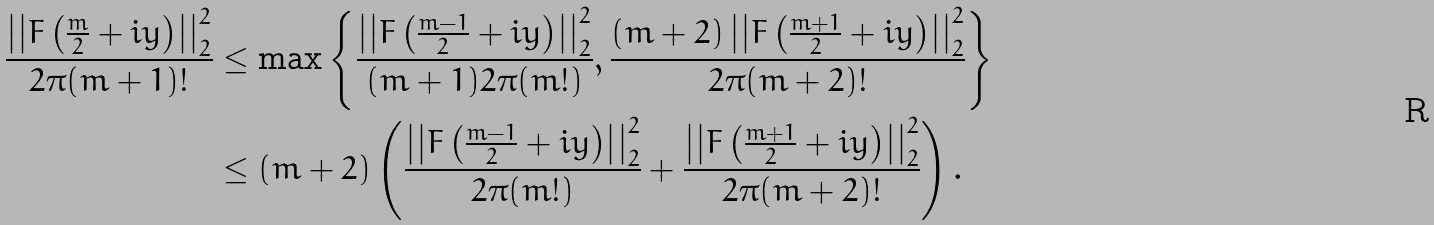<formula> <loc_0><loc_0><loc_500><loc_500>\frac { \left | \left | F \left ( \frac { m } { 2 } + i y \right ) \right | \right | _ { 2 } ^ { 2 } } { 2 \pi ( m + 1 ) ! } & \leq \max \left \{ \frac { \left | \left | F \left ( \frac { m - 1 } { 2 } + i y \right ) \right | \right | _ { 2 } ^ { 2 } } { ( m + 1 ) 2 \pi ( m ! ) } , \frac { ( m + 2 ) \left | \left | F \left ( \frac { m + 1 } { 2 } + i y \right ) \right | \right | _ { 2 } ^ { 2 } } { 2 \pi ( m + 2 ) ! } \right \} \\ & \leq ( m + 2 ) \left ( \frac { \left | \left | F \left ( \frac { m - 1 } { 2 } + i y \right ) \right | \right | _ { 2 } ^ { 2 } } { 2 \pi ( m ! ) } + \frac { \left | \left | F \left ( \frac { m + 1 } { 2 } + i y \right ) \right | \right | _ { 2 } ^ { 2 } } { 2 \pi ( m + 2 ) ! } \right ) .</formula> 